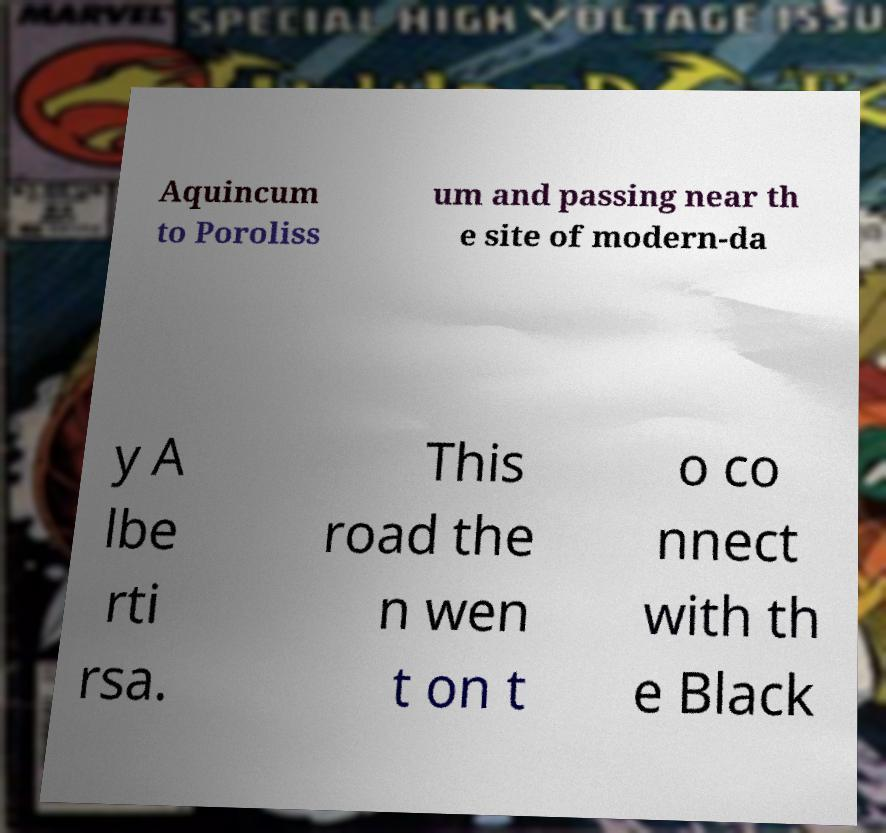Can you read and provide the text displayed in the image?This photo seems to have some interesting text. Can you extract and type it out for me? Aquincum to Poroliss um and passing near th e site of modern-da y A lbe rti rsa. This road the n wen t on t o co nnect with th e Black 